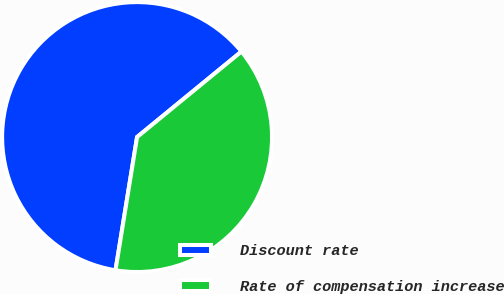Convert chart to OTSL. <chart><loc_0><loc_0><loc_500><loc_500><pie_chart><fcel>Discount rate<fcel>Rate of compensation increase<nl><fcel>61.52%<fcel>38.48%<nl></chart> 